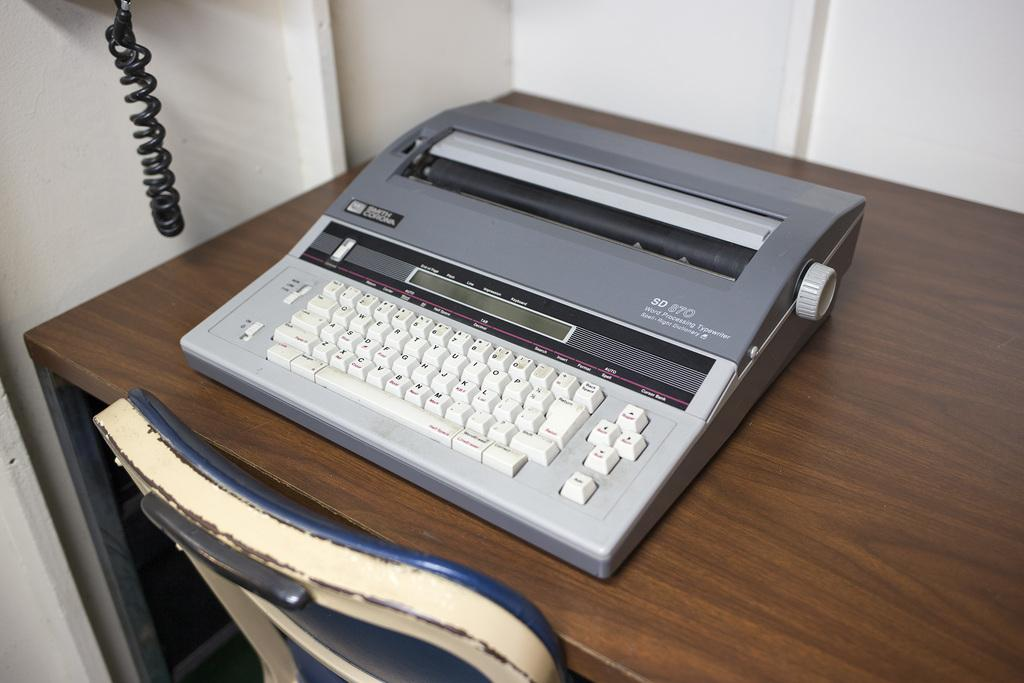<image>
Give a short and clear explanation of the subsequent image. An SD 870 word processing typewriter sits on a desk. 